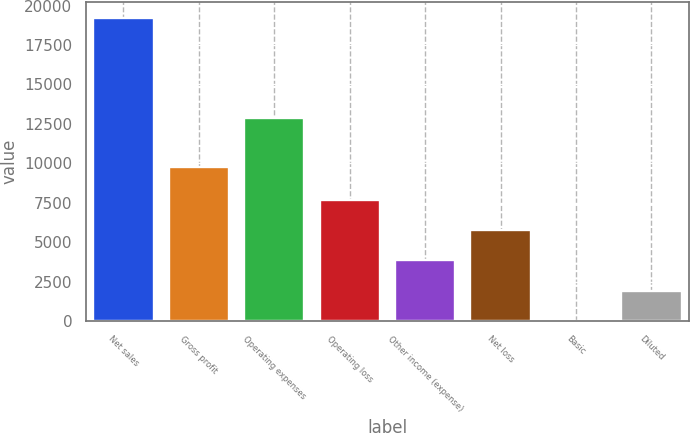Convert chart. <chart><loc_0><loc_0><loc_500><loc_500><bar_chart><fcel>Net sales<fcel>Gross profit<fcel>Operating expenses<fcel>Operating loss<fcel>Other income (expense)<fcel>Net loss<fcel>Basic<fcel>Diluted<nl><fcel>19235<fcel>9741<fcel>12877<fcel>7694.08<fcel>3847.1<fcel>5770.59<fcel>0.12<fcel>1923.61<nl></chart> 